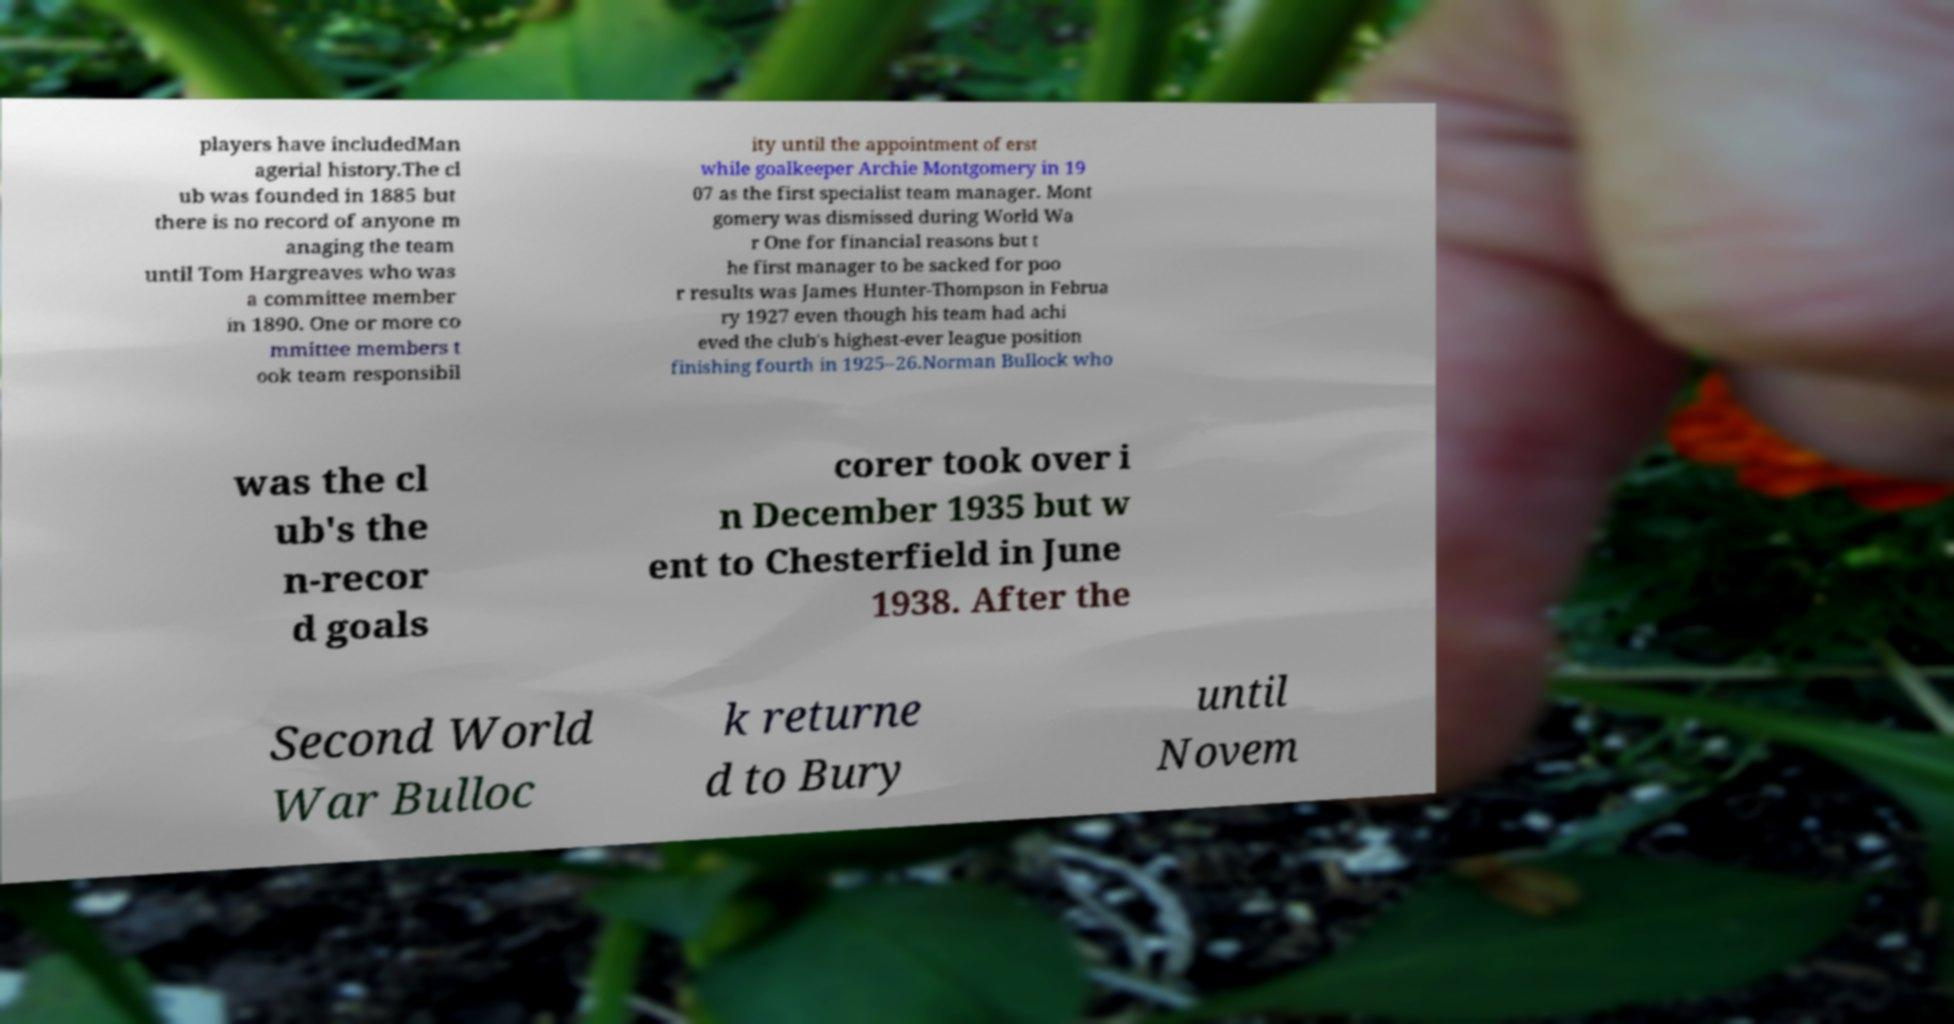There's text embedded in this image that I need extracted. Can you transcribe it verbatim? players have includedMan agerial history.The cl ub was founded in 1885 but there is no record of anyone m anaging the team until Tom Hargreaves who was a committee member in 1890. One or more co mmittee members t ook team responsibil ity until the appointment of erst while goalkeeper Archie Montgomery in 19 07 as the first specialist team manager. Mont gomery was dismissed during World Wa r One for financial reasons but t he first manager to be sacked for poo r results was James Hunter-Thompson in Februa ry 1927 even though his team had achi eved the club's highest-ever league position finishing fourth in 1925–26.Norman Bullock who was the cl ub's the n-recor d goals corer took over i n December 1935 but w ent to Chesterfield in June 1938. After the Second World War Bulloc k returne d to Bury until Novem 